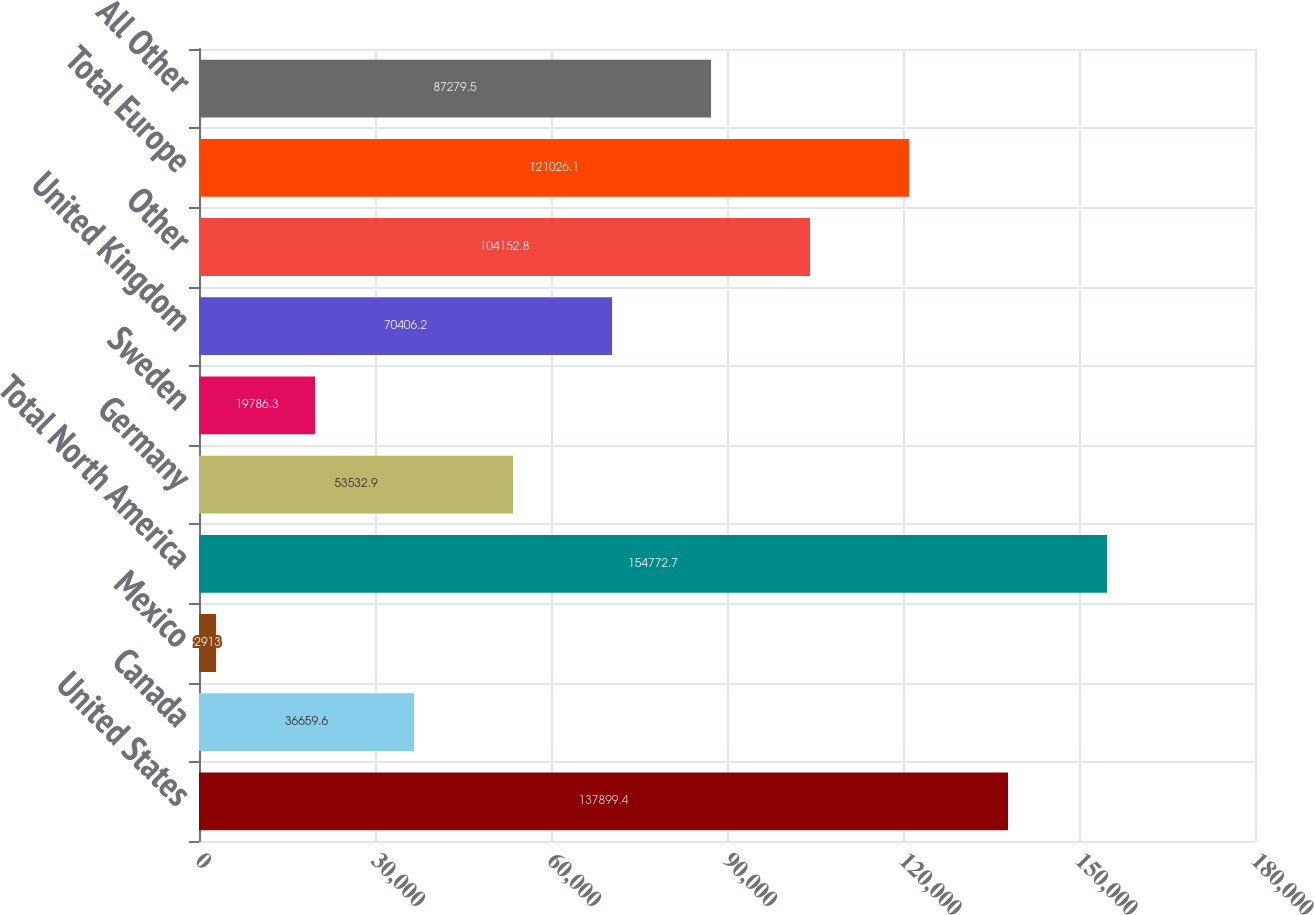Convert chart. <chart><loc_0><loc_0><loc_500><loc_500><bar_chart><fcel>United States<fcel>Canada<fcel>Mexico<fcel>Total North America<fcel>Germany<fcel>Sweden<fcel>United Kingdom<fcel>Other<fcel>Total Europe<fcel>All Other<nl><fcel>137899<fcel>36659.6<fcel>2913<fcel>154773<fcel>53532.9<fcel>19786.3<fcel>70406.2<fcel>104153<fcel>121026<fcel>87279.5<nl></chart> 